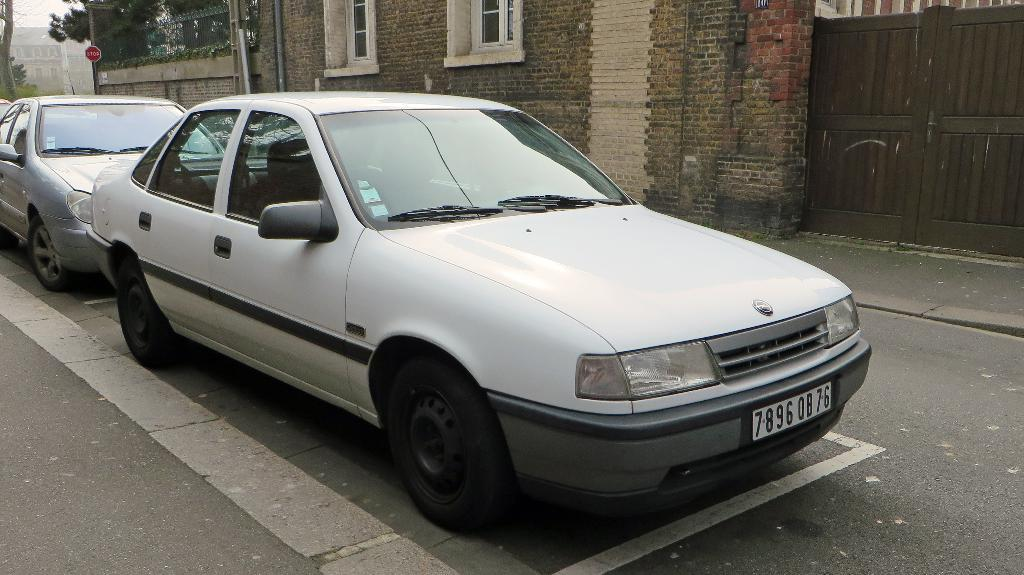What is in the center of the image? There are cars on the road in the center of the image. What can be seen in the background of the image? There are buildings and trees in the background of the image. Is there any text visible in the image? Yes, there is a board with text written on it in the background of the image. What type of steel is used to construct the crook in the image? There is no crook or steel present in the image. 